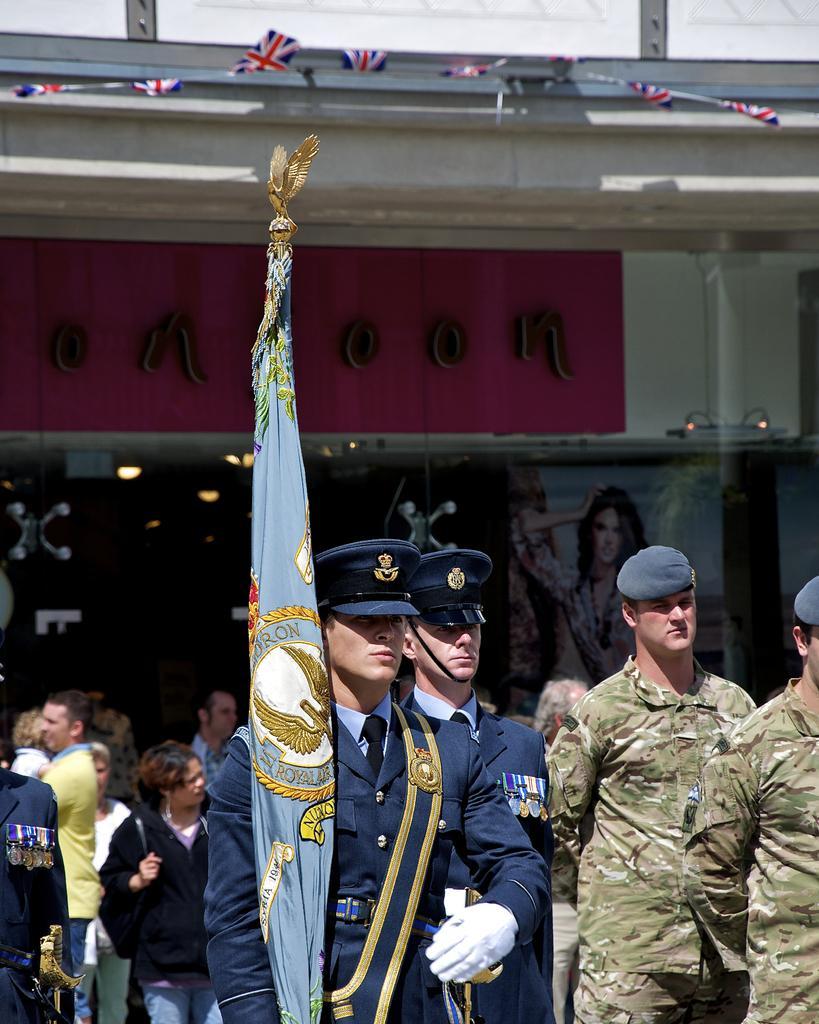Please provide a concise description of this image. As we can see in the image there are few people here and there and a building. The man over here is holding a flag. 